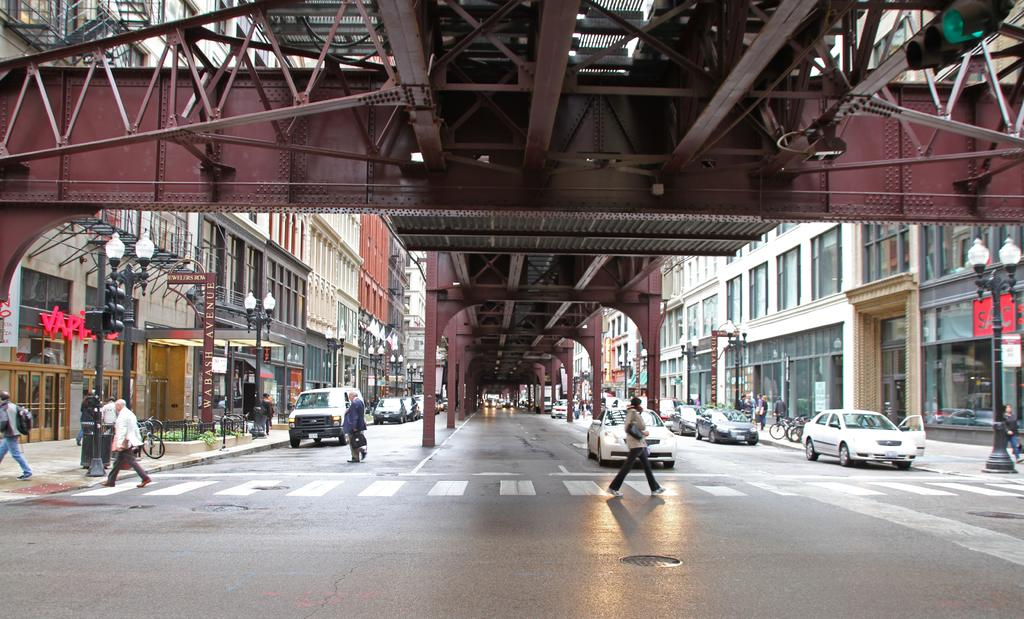<image>
Create a compact narrative representing the image presented. A street scene with a shop with the word Sac on it to the right 